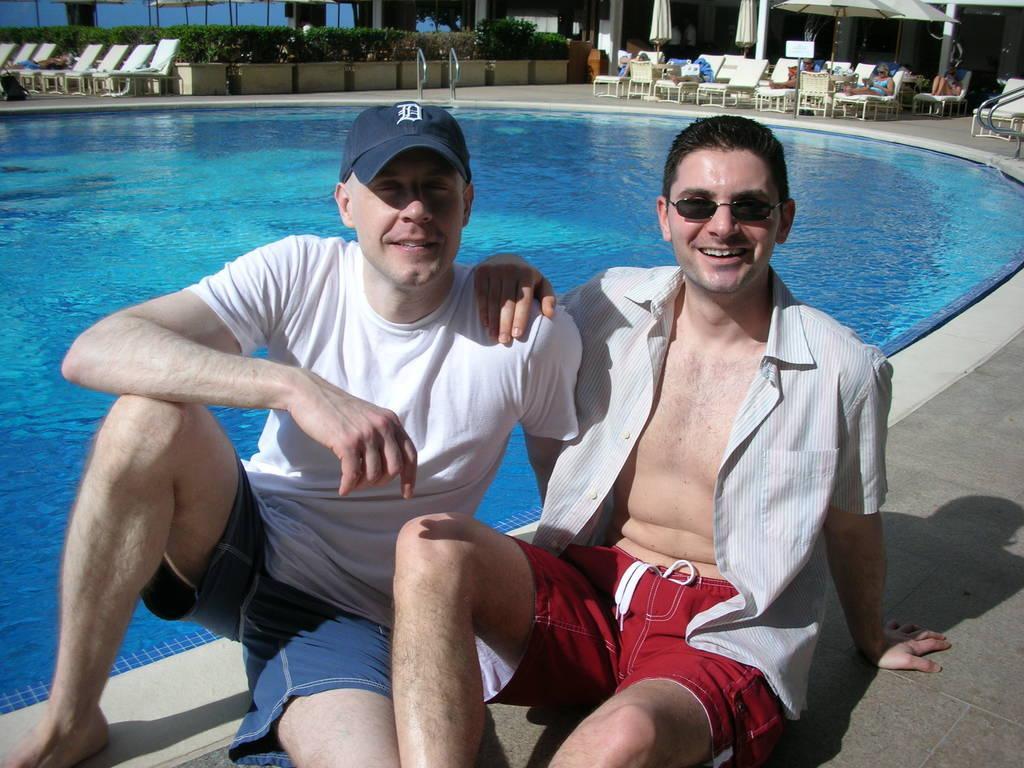Could you give a brief overview of what you see in this image? In the image we can see the people sitting in the front are laughing. The first person is wearing a white color shirt and a cap and the second person is wearing goggles. Beside these two persons there is a swimming pool and behind, there are some chairs and some plants. In these chairs there are some people sitting. 